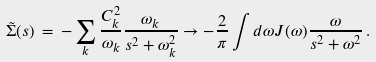Convert formula to latex. <formula><loc_0><loc_0><loc_500><loc_500>\tilde { \Sigma } ( s ) \, = \, - \sum _ { k } \frac { C _ { k } ^ { 2 } } { \omega _ { k } } \frac { \omega _ { k } } { s ^ { 2 } + \omega _ { k } ^ { 2 } } \rightarrow - \frac { 2 } { \pi } \int d \omega J ( \omega ) \frac { \omega } { s ^ { 2 } + \omega ^ { 2 } } \, .</formula> 